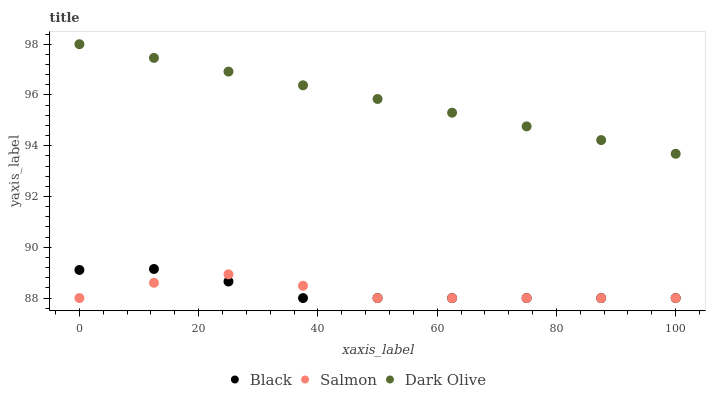Does Salmon have the minimum area under the curve?
Answer yes or no. Yes. Does Dark Olive have the maximum area under the curve?
Answer yes or no. Yes. Does Black have the minimum area under the curve?
Answer yes or no. No. Does Black have the maximum area under the curve?
Answer yes or no. No. Is Dark Olive the smoothest?
Answer yes or no. Yes. Is Salmon the roughest?
Answer yes or no. Yes. Is Black the smoothest?
Answer yes or no. No. Is Black the roughest?
Answer yes or no. No. Does Salmon have the lowest value?
Answer yes or no. Yes. Does Dark Olive have the lowest value?
Answer yes or no. No. Does Dark Olive have the highest value?
Answer yes or no. Yes. Does Black have the highest value?
Answer yes or no. No. Is Salmon less than Dark Olive?
Answer yes or no. Yes. Is Dark Olive greater than Salmon?
Answer yes or no. Yes. Does Black intersect Salmon?
Answer yes or no. Yes. Is Black less than Salmon?
Answer yes or no. No. Is Black greater than Salmon?
Answer yes or no. No. Does Salmon intersect Dark Olive?
Answer yes or no. No. 